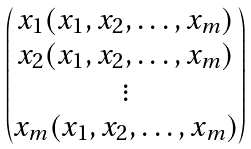<formula> <loc_0><loc_0><loc_500><loc_500>\begin{pmatrix} x _ { 1 } ( x _ { 1 } , x _ { 2 } , \dots , x _ { m } ) \\ x _ { 2 } ( x _ { 1 } , x _ { 2 } , \dots , x _ { m } ) \\ \vdots \\ x _ { m } ( x _ { 1 } , x _ { 2 } , \dots , x _ { m } ) \\ \end{pmatrix}</formula> 